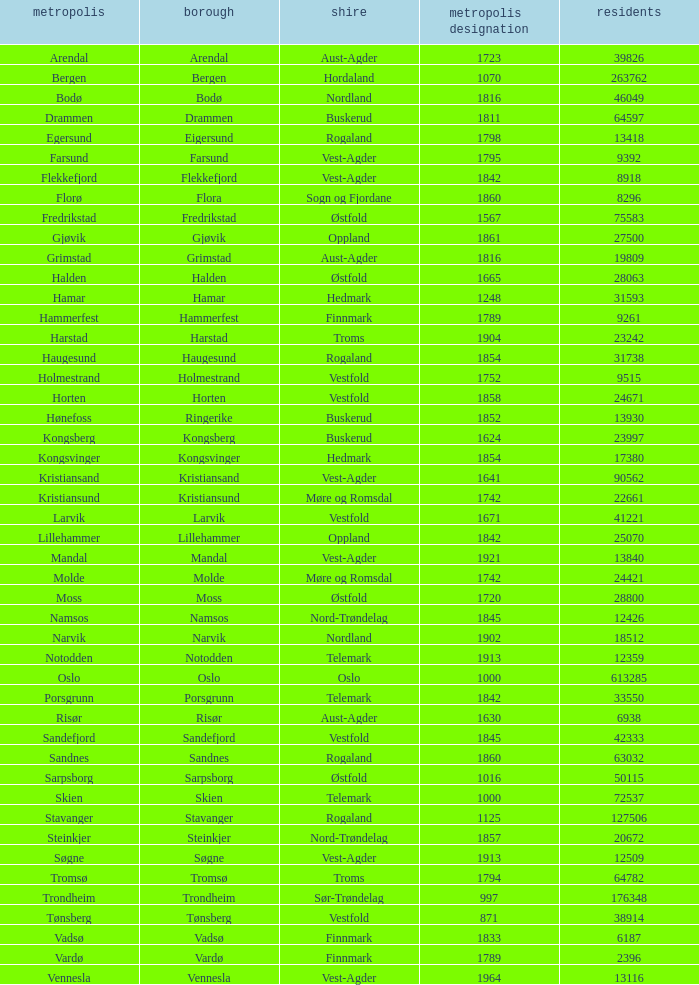Which municipalities located in the county of Finnmark have populations bigger than 6187.0? Hammerfest. 